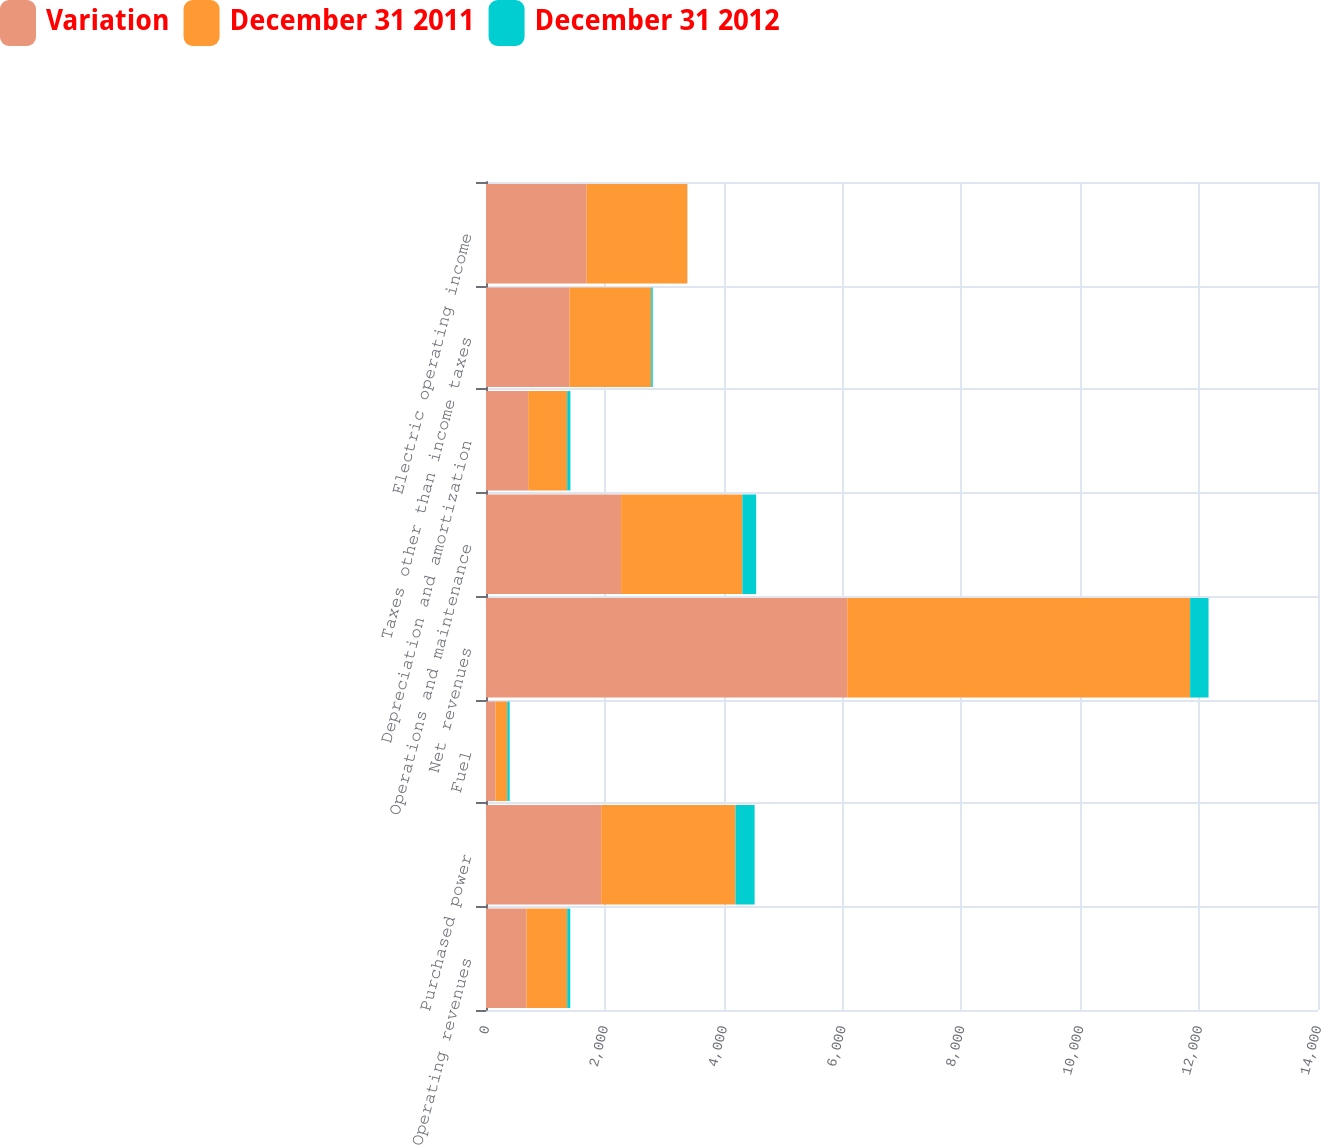Convert chart. <chart><loc_0><loc_0><loc_500><loc_500><stacked_bar_chart><ecel><fcel>Operating revenues<fcel>Purchased power<fcel>Fuel<fcel>Net revenues<fcel>Operations and maintenance<fcel>Depreciation and amortization<fcel>Taxes other than income taxes<fcel>Electric operating income<nl><fcel>Variation<fcel>683<fcel>1938<fcel>159<fcel>6079<fcel>2273<fcel>710<fcel>1403<fcel>1693<nl><fcel>December 31 2011<fcel>683<fcel>2260<fcel>199<fcel>5769<fcel>2041<fcel>656<fcel>1377<fcel>1695<nl><fcel>December 31 2012<fcel>52<fcel>322<fcel>40<fcel>310<fcel>232<fcel>54<fcel>26<fcel>2<nl></chart> 